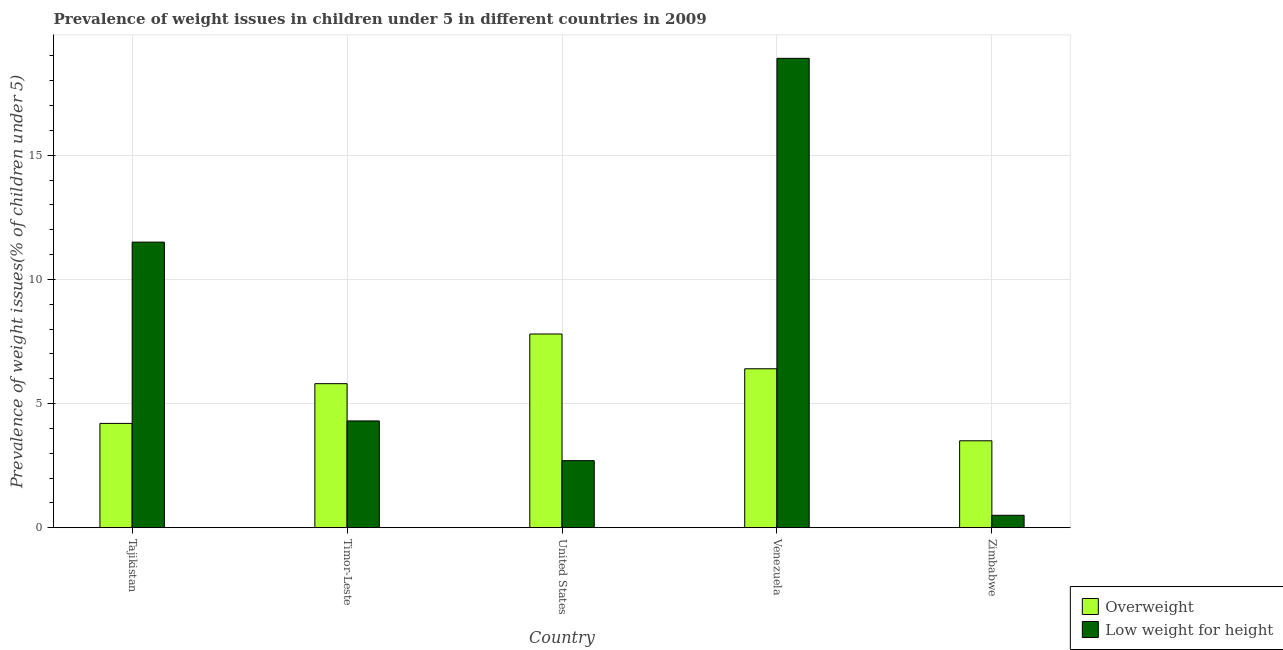How many different coloured bars are there?
Your answer should be compact. 2. Are the number of bars on each tick of the X-axis equal?
Make the answer very short. Yes. How many bars are there on the 2nd tick from the left?
Provide a succinct answer. 2. How many bars are there on the 4th tick from the right?
Your answer should be very brief. 2. What is the label of the 2nd group of bars from the left?
Provide a succinct answer. Timor-Leste. In how many cases, is the number of bars for a given country not equal to the number of legend labels?
Make the answer very short. 0. What is the percentage of underweight children in Tajikistan?
Ensure brevity in your answer.  11.5. Across all countries, what is the maximum percentage of underweight children?
Offer a terse response. 18.9. Across all countries, what is the minimum percentage of underweight children?
Your answer should be very brief. 0.5. In which country was the percentage of underweight children maximum?
Make the answer very short. Venezuela. In which country was the percentage of underweight children minimum?
Make the answer very short. Zimbabwe. What is the total percentage of underweight children in the graph?
Provide a short and direct response. 37.9. What is the difference between the percentage of underweight children in Timor-Leste and that in United States?
Make the answer very short. 1.6. What is the difference between the percentage of underweight children in Timor-Leste and the percentage of overweight children in Venezuela?
Provide a succinct answer. -2.1. What is the average percentage of overweight children per country?
Provide a short and direct response. 5.54. What is the difference between the percentage of overweight children and percentage of underweight children in Tajikistan?
Make the answer very short. -7.3. What is the ratio of the percentage of underweight children in United States to that in Venezuela?
Offer a very short reply. 0.14. Is the percentage of overweight children in Tajikistan less than that in Venezuela?
Offer a terse response. Yes. Is the difference between the percentage of overweight children in Tajikistan and United States greater than the difference between the percentage of underweight children in Tajikistan and United States?
Provide a succinct answer. No. What is the difference between the highest and the second highest percentage of underweight children?
Provide a short and direct response. 7.4. What is the difference between the highest and the lowest percentage of overweight children?
Keep it short and to the point. 4.3. In how many countries, is the percentage of underweight children greater than the average percentage of underweight children taken over all countries?
Your answer should be compact. 2. Is the sum of the percentage of underweight children in Tajikistan and Zimbabwe greater than the maximum percentage of overweight children across all countries?
Offer a terse response. Yes. What does the 2nd bar from the left in Timor-Leste represents?
Make the answer very short. Low weight for height. What does the 1st bar from the right in Venezuela represents?
Your answer should be compact. Low weight for height. How many bars are there?
Keep it short and to the point. 10. Are all the bars in the graph horizontal?
Make the answer very short. No. How many countries are there in the graph?
Offer a very short reply. 5. Does the graph contain any zero values?
Provide a succinct answer. No. How many legend labels are there?
Keep it short and to the point. 2. How are the legend labels stacked?
Give a very brief answer. Vertical. What is the title of the graph?
Ensure brevity in your answer.  Prevalence of weight issues in children under 5 in different countries in 2009. What is the label or title of the X-axis?
Your answer should be very brief. Country. What is the label or title of the Y-axis?
Your answer should be very brief. Prevalence of weight issues(% of children under 5). What is the Prevalence of weight issues(% of children under 5) in Overweight in Tajikistan?
Offer a very short reply. 4.2. What is the Prevalence of weight issues(% of children under 5) in Low weight for height in Tajikistan?
Your answer should be very brief. 11.5. What is the Prevalence of weight issues(% of children under 5) of Overweight in Timor-Leste?
Provide a succinct answer. 5.8. What is the Prevalence of weight issues(% of children under 5) in Low weight for height in Timor-Leste?
Provide a succinct answer. 4.3. What is the Prevalence of weight issues(% of children under 5) in Overweight in United States?
Provide a short and direct response. 7.8. What is the Prevalence of weight issues(% of children under 5) of Low weight for height in United States?
Offer a very short reply. 2.7. What is the Prevalence of weight issues(% of children under 5) of Overweight in Venezuela?
Keep it short and to the point. 6.4. What is the Prevalence of weight issues(% of children under 5) in Low weight for height in Venezuela?
Your answer should be very brief. 18.9. What is the Prevalence of weight issues(% of children under 5) of Overweight in Zimbabwe?
Provide a short and direct response. 3.5. Across all countries, what is the maximum Prevalence of weight issues(% of children under 5) in Overweight?
Give a very brief answer. 7.8. Across all countries, what is the maximum Prevalence of weight issues(% of children under 5) in Low weight for height?
Your answer should be compact. 18.9. Across all countries, what is the minimum Prevalence of weight issues(% of children under 5) of Overweight?
Ensure brevity in your answer.  3.5. Across all countries, what is the minimum Prevalence of weight issues(% of children under 5) in Low weight for height?
Provide a succinct answer. 0.5. What is the total Prevalence of weight issues(% of children under 5) of Overweight in the graph?
Ensure brevity in your answer.  27.7. What is the total Prevalence of weight issues(% of children under 5) of Low weight for height in the graph?
Your answer should be very brief. 37.9. What is the difference between the Prevalence of weight issues(% of children under 5) of Overweight in Tajikistan and that in Timor-Leste?
Provide a short and direct response. -1.6. What is the difference between the Prevalence of weight issues(% of children under 5) in Overweight in Tajikistan and that in United States?
Offer a very short reply. -3.6. What is the difference between the Prevalence of weight issues(% of children under 5) of Overweight in Tajikistan and that in Venezuela?
Your answer should be very brief. -2.2. What is the difference between the Prevalence of weight issues(% of children under 5) of Overweight in Tajikistan and that in Zimbabwe?
Make the answer very short. 0.7. What is the difference between the Prevalence of weight issues(% of children under 5) of Low weight for height in Tajikistan and that in Zimbabwe?
Offer a very short reply. 11. What is the difference between the Prevalence of weight issues(% of children under 5) of Overweight in Timor-Leste and that in United States?
Provide a short and direct response. -2. What is the difference between the Prevalence of weight issues(% of children under 5) of Low weight for height in Timor-Leste and that in Venezuela?
Provide a succinct answer. -14.6. What is the difference between the Prevalence of weight issues(% of children under 5) in Overweight in Timor-Leste and that in Zimbabwe?
Your response must be concise. 2.3. What is the difference between the Prevalence of weight issues(% of children under 5) of Low weight for height in Timor-Leste and that in Zimbabwe?
Your answer should be compact. 3.8. What is the difference between the Prevalence of weight issues(% of children under 5) of Overweight in United States and that in Venezuela?
Offer a terse response. 1.4. What is the difference between the Prevalence of weight issues(% of children under 5) in Low weight for height in United States and that in Venezuela?
Make the answer very short. -16.2. What is the difference between the Prevalence of weight issues(% of children under 5) of Low weight for height in United States and that in Zimbabwe?
Provide a short and direct response. 2.2. What is the difference between the Prevalence of weight issues(% of children under 5) of Overweight in Venezuela and that in Zimbabwe?
Your response must be concise. 2.9. What is the difference between the Prevalence of weight issues(% of children under 5) of Overweight in Tajikistan and the Prevalence of weight issues(% of children under 5) of Low weight for height in Timor-Leste?
Make the answer very short. -0.1. What is the difference between the Prevalence of weight issues(% of children under 5) of Overweight in Tajikistan and the Prevalence of weight issues(% of children under 5) of Low weight for height in United States?
Your response must be concise. 1.5. What is the difference between the Prevalence of weight issues(% of children under 5) in Overweight in Tajikistan and the Prevalence of weight issues(% of children under 5) in Low weight for height in Venezuela?
Your response must be concise. -14.7. What is the difference between the Prevalence of weight issues(% of children under 5) in Overweight in Timor-Leste and the Prevalence of weight issues(% of children under 5) in Low weight for height in United States?
Provide a succinct answer. 3.1. What is the difference between the Prevalence of weight issues(% of children under 5) of Overweight in Timor-Leste and the Prevalence of weight issues(% of children under 5) of Low weight for height in Venezuela?
Make the answer very short. -13.1. What is the difference between the Prevalence of weight issues(% of children under 5) of Overweight in Venezuela and the Prevalence of weight issues(% of children under 5) of Low weight for height in Zimbabwe?
Your response must be concise. 5.9. What is the average Prevalence of weight issues(% of children under 5) of Overweight per country?
Provide a short and direct response. 5.54. What is the average Prevalence of weight issues(% of children under 5) in Low weight for height per country?
Keep it short and to the point. 7.58. What is the ratio of the Prevalence of weight issues(% of children under 5) in Overweight in Tajikistan to that in Timor-Leste?
Provide a succinct answer. 0.72. What is the ratio of the Prevalence of weight issues(% of children under 5) of Low weight for height in Tajikistan to that in Timor-Leste?
Offer a very short reply. 2.67. What is the ratio of the Prevalence of weight issues(% of children under 5) in Overweight in Tajikistan to that in United States?
Your answer should be very brief. 0.54. What is the ratio of the Prevalence of weight issues(% of children under 5) in Low weight for height in Tajikistan to that in United States?
Your answer should be very brief. 4.26. What is the ratio of the Prevalence of weight issues(% of children under 5) of Overweight in Tajikistan to that in Venezuela?
Your answer should be compact. 0.66. What is the ratio of the Prevalence of weight issues(% of children under 5) in Low weight for height in Tajikistan to that in Venezuela?
Make the answer very short. 0.61. What is the ratio of the Prevalence of weight issues(% of children under 5) of Overweight in Timor-Leste to that in United States?
Give a very brief answer. 0.74. What is the ratio of the Prevalence of weight issues(% of children under 5) of Low weight for height in Timor-Leste to that in United States?
Offer a very short reply. 1.59. What is the ratio of the Prevalence of weight issues(% of children under 5) in Overweight in Timor-Leste to that in Venezuela?
Ensure brevity in your answer.  0.91. What is the ratio of the Prevalence of weight issues(% of children under 5) of Low weight for height in Timor-Leste to that in Venezuela?
Provide a succinct answer. 0.23. What is the ratio of the Prevalence of weight issues(% of children under 5) of Overweight in Timor-Leste to that in Zimbabwe?
Offer a terse response. 1.66. What is the ratio of the Prevalence of weight issues(% of children under 5) in Low weight for height in Timor-Leste to that in Zimbabwe?
Provide a short and direct response. 8.6. What is the ratio of the Prevalence of weight issues(% of children under 5) of Overweight in United States to that in Venezuela?
Provide a short and direct response. 1.22. What is the ratio of the Prevalence of weight issues(% of children under 5) of Low weight for height in United States to that in Venezuela?
Provide a succinct answer. 0.14. What is the ratio of the Prevalence of weight issues(% of children under 5) of Overweight in United States to that in Zimbabwe?
Your response must be concise. 2.23. What is the ratio of the Prevalence of weight issues(% of children under 5) of Low weight for height in United States to that in Zimbabwe?
Your answer should be compact. 5.4. What is the ratio of the Prevalence of weight issues(% of children under 5) in Overweight in Venezuela to that in Zimbabwe?
Keep it short and to the point. 1.83. What is the ratio of the Prevalence of weight issues(% of children under 5) of Low weight for height in Venezuela to that in Zimbabwe?
Provide a short and direct response. 37.8. What is the difference between the highest and the second highest Prevalence of weight issues(% of children under 5) of Low weight for height?
Offer a terse response. 7.4. What is the difference between the highest and the lowest Prevalence of weight issues(% of children under 5) of Overweight?
Your answer should be very brief. 4.3. What is the difference between the highest and the lowest Prevalence of weight issues(% of children under 5) in Low weight for height?
Provide a short and direct response. 18.4. 